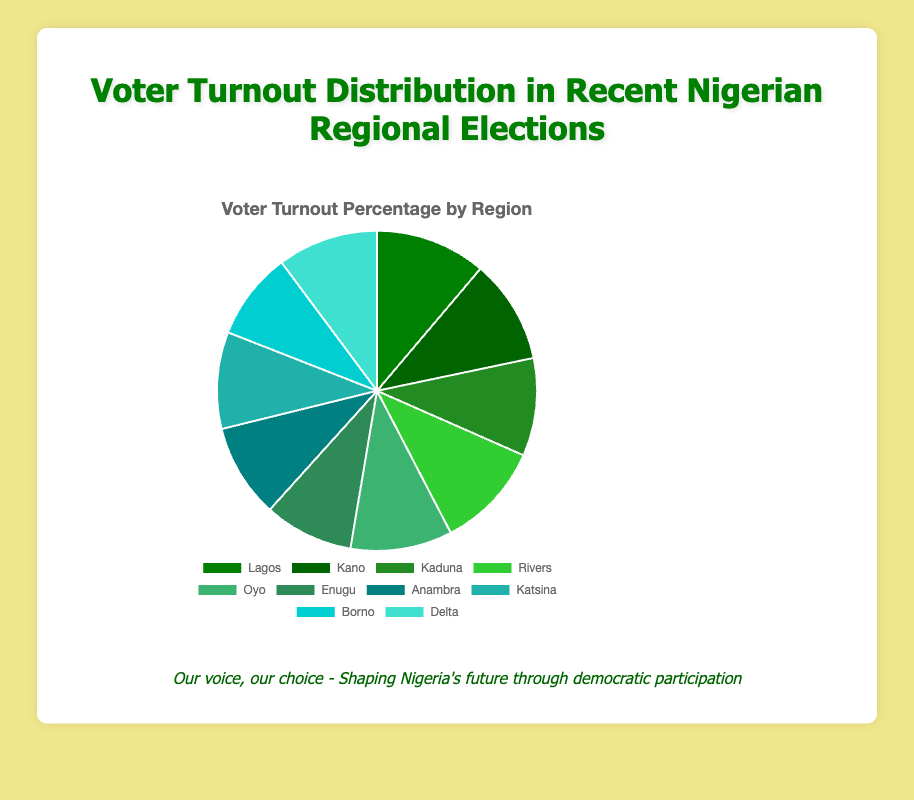Which region has the highest voter turnout percentage? Lagos has the highest voter turnout percentage of 62.4% as shown on the pie chart.
Answer: Lagos Which region has the lowest voter turnout percentage? Borno has the lowest voter turnout percentage of 49.5% as depicted on the pie chart.
Answer: Borno Compare the voter turnout percentage between Rivers and Delta. Which is higher? Rivers and Delta have voter turnout percentages of 60.1% and 56.8%, respectively. Rivers has a higher voter turnout percentage.
Answer: Rivers What is the total voter turnout percentage of Lagos and Kano combined? The voter turnout percentage for Lagos is 62.4%, and for Kano, it is 58.7%. Adding these together: 62.4 + 58.7 = 121.1%.
Answer: 121.1% Which region's voter turnout is closest in percentage to Oyo's voter turnout? Oyo's voter turnout is 57.4%. The closest in percentage is Kano with 58.7%.
Answer: Kano What is the average voter turnout percentage of Kaduna, Enugu, and Anambra? The voter turnout percentages are: Kaduna 55.2%, Enugu 50.3%, and Anambra 52.9%. Their average is (55.2 + 50.3 + 52.9) / 3 = 52.8%.
Answer: 52.8% Is the voter turnout percentage in Katsina higher or lower than the overall average voter turnout? The voter turnout for Katsina is 54.6%. The overall average can be calculated by summing all percentages and dividing by the number of regions: (62.4 + 58.7 + 55.2 + 60.1 + 57.4 + 50.3 + 52.9 + 54.6 + 49.5 + 56.8) / 10 = 55.8%. Katsina's 54.6% is lower than the overall average.
Answer: Lower Which regions have a voter turnout percentage greater than 60%? The regions with a voter turnout percentage greater than 60% are Lagos (62.4%) and Rivers (60.1%).
Answer: Lagos, Rivers How much more is Lagos's voter turnout percentage compared to Borno's? Lagos's voter turnout is 62.4%, and Borno's is 49.5%. The difference is 62.4 - 49.5 = 12.9%.
Answer: 12.9% What is the sum of voter turnout percentages for the regions in the North? (Assume the northern regions are Kano, Kaduna, Katsina, and Borno) The voter turnout percentages are: Kano 58.7%, Kaduna 55.2%, Katsina 54.6%, and Borno 49.5%. The sum is 58.7 + 55.2 + 54.6 + 49.5 = 218%.
Answer: 218% 